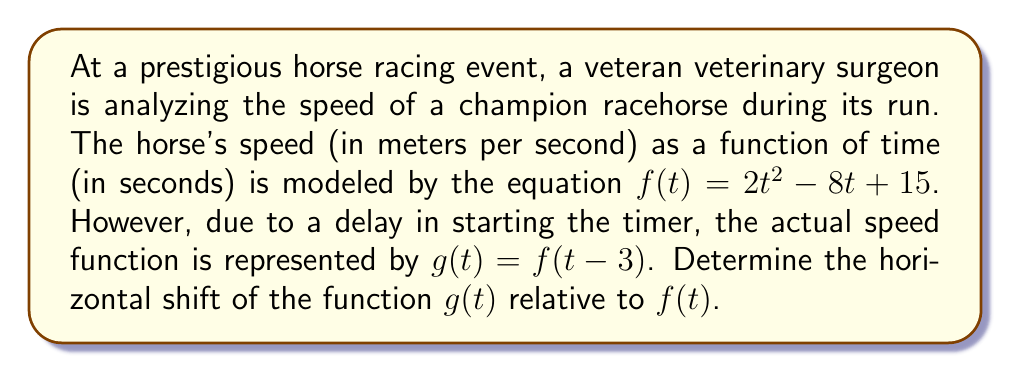Can you answer this question? To determine the horizontal shift of the function $g(t)$ relative to $f(t)$, we need to analyze the transformation applied to $f(t)$.

1) The given functions are:
   $f(t) = 2t^2 - 8t + 15$
   $g(t) = f(t-3)$

2) In general, when we have a function in the form $g(t) = f(t-h)$, it represents a horizontal shift of the function $f(t)$ by $h$ units to the right if $h$ is positive, or $h$ units to the left if $h$ is negative.

3) In our case, $g(t) = f(t-3)$, which means we're replacing every $t$ in $f(t)$ with $(t-3)$.

4) This transformation can be interpreted as: for any given input $t$ in $g(t)$, we first subtract 3 from it before inputting it into $f(t)$. 

5) Alternatively, we can think of this as: to get the same y-value in $g(t)$ as we had in $f(t)$, we need to input a value that is 3 units greater.

6) This indicates that the graph of $g(t)$ is shifted 3 units to the right compared to $f(t)$.

Therefore, the function $g(t)$ represents a horizontal shift of $f(t)$ by 3 units to the right.
Answer: The horizontal shift of $g(t)$ relative to $f(t)$ is 3 units to the right. 